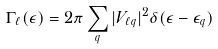Convert formula to latex. <formula><loc_0><loc_0><loc_500><loc_500>\Gamma _ { \ell } ( \epsilon ) = 2 \pi \sum _ { q } | V _ { \ell q } | ^ { 2 } \delta ( \epsilon - \epsilon _ { q } )</formula> 